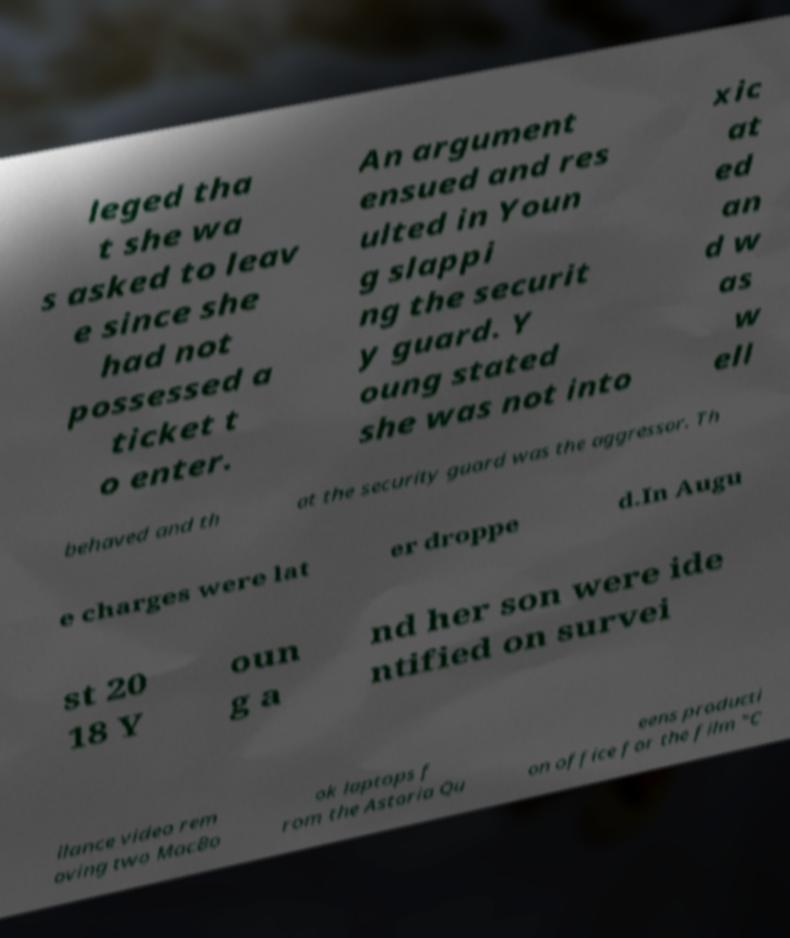For documentation purposes, I need the text within this image transcribed. Could you provide that? leged tha t she wa s asked to leav e since she had not possessed a ticket t o enter. An argument ensued and res ulted in Youn g slappi ng the securit y guard. Y oung stated she was not into xic at ed an d w as w ell behaved and th at the security guard was the aggressor. Th e charges were lat er droppe d.In Augu st 20 18 Y oun g a nd her son were ide ntified on survei llance video rem oving two MacBo ok laptops f rom the Astoria Qu eens producti on office for the film "C 